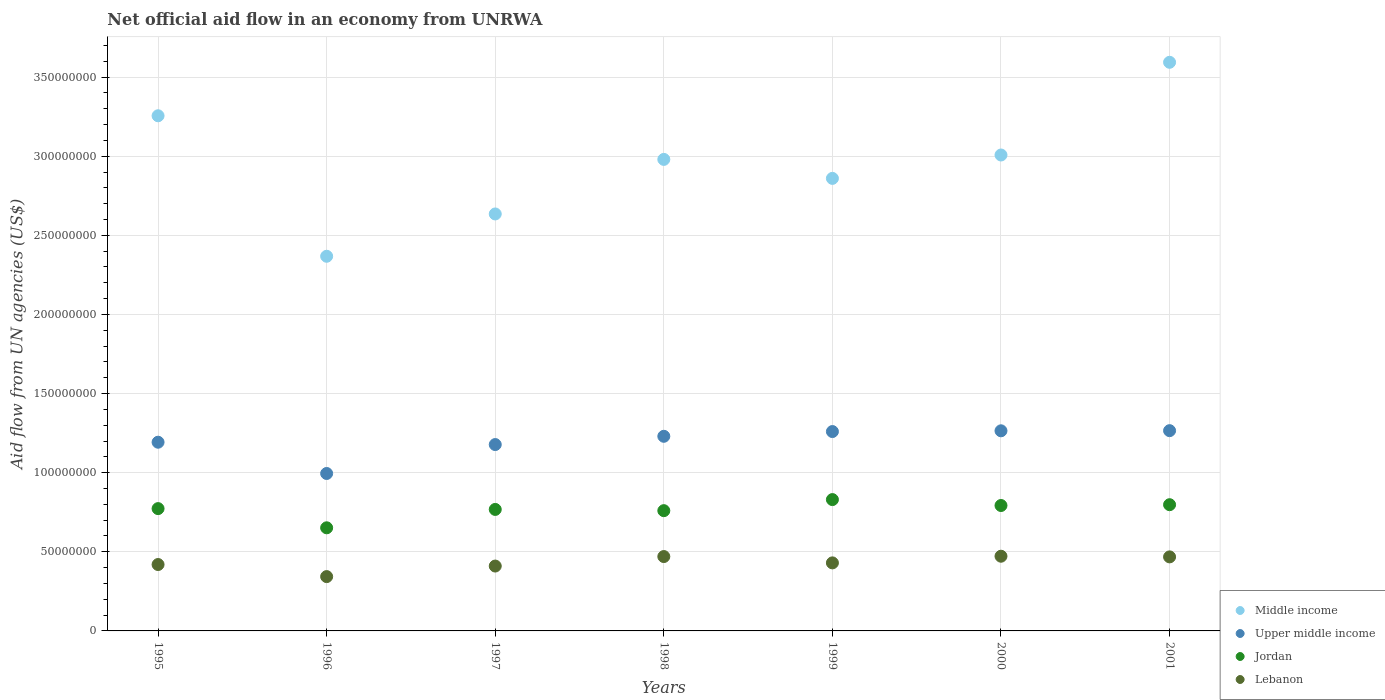What is the net official aid flow in Lebanon in 1999?
Ensure brevity in your answer.  4.30e+07. Across all years, what is the maximum net official aid flow in Upper middle income?
Your answer should be very brief. 1.27e+08. Across all years, what is the minimum net official aid flow in Upper middle income?
Offer a terse response. 9.95e+07. In which year was the net official aid flow in Middle income minimum?
Your answer should be very brief. 1996. What is the total net official aid flow in Upper middle income in the graph?
Offer a terse response. 8.39e+08. What is the difference between the net official aid flow in Lebanon in 1997 and that in 1998?
Keep it short and to the point. -6.00e+06. What is the difference between the net official aid flow in Jordan in 1998 and the net official aid flow in Middle income in 2001?
Keep it short and to the point. -2.83e+08. What is the average net official aid flow in Jordan per year?
Give a very brief answer. 7.68e+07. In the year 2001, what is the difference between the net official aid flow in Upper middle income and net official aid flow in Middle income?
Offer a terse response. -2.33e+08. What is the ratio of the net official aid flow in Upper middle income in 1999 to that in 2000?
Your response must be concise. 1. Is the net official aid flow in Lebanon in 1998 less than that in 2000?
Offer a very short reply. Yes. What is the difference between the highest and the second highest net official aid flow in Middle income?
Keep it short and to the point. 3.38e+07. What is the difference between the highest and the lowest net official aid flow in Jordan?
Provide a succinct answer. 1.78e+07. In how many years, is the net official aid flow in Lebanon greater than the average net official aid flow in Lebanon taken over all years?
Ensure brevity in your answer.  3. Is the sum of the net official aid flow in Upper middle income in 1997 and 1999 greater than the maximum net official aid flow in Jordan across all years?
Ensure brevity in your answer.  Yes. Is it the case that in every year, the sum of the net official aid flow in Jordan and net official aid flow in Upper middle income  is greater than the sum of net official aid flow in Middle income and net official aid flow in Lebanon?
Your answer should be compact. No. Does the net official aid flow in Lebanon monotonically increase over the years?
Your answer should be very brief. No. Is the net official aid flow in Upper middle income strictly greater than the net official aid flow in Jordan over the years?
Offer a very short reply. Yes. Is the net official aid flow in Jordan strictly less than the net official aid flow in Middle income over the years?
Your answer should be very brief. Yes. What is the difference between two consecutive major ticks on the Y-axis?
Ensure brevity in your answer.  5.00e+07. Does the graph contain any zero values?
Provide a short and direct response. No. Does the graph contain grids?
Offer a very short reply. Yes. How are the legend labels stacked?
Ensure brevity in your answer.  Vertical. What is the title of the graph?
Your answer should be compact. Net official aid flow in an economy from UNRWA. Does "United States" appear as one of the legend labels in the graph?
Give a very brief answer. No. What is the label or title of the Y-axis?
Your response must be concise. Aid flow from UN agencies (US$). What is the Aid flow from UN agencies (US$) in Middle income in 1995?
Provide a succinct answer. 3.26e+08. What is the Aid flow from UN agencies (US$) of Upper middle income in 1995?
Your answer should be very brief. 1.19e+08. What is the Aid flow from UN agencies (US$) of Jordan in 1995?
Ensure brevity in your answer.  7.73e+07. What is the Aid flow from UN agencies (US$) of Lebanon in 1995?
Provide a short and direct response. 4.20e+07. What is the Aid flow from UN agencies (US$) of Middle income in 1996?
Your answer should be compact. 2.37e+08. What is the Aid flow from UN agencies (US$) of Upper middle income in 1996?
Ensure brevity in your answer.  9.95e+07. What is the Aid flow from UN agencies (US$) in Jordan in 1996?
Your response must be concise. 6.52e+07. What is the Aid flow from UN agencies (US$) in Lebanon in 1996?
Your answer should be very brief. 3.43e+07. What is the Aid flow from UN agencies (US$) in Middle income in 1997?
Your answer should be compact. 2.64e+08. What is the Aid flow from UN agencies (US$) of Upper middle income in 1997?
Keep it short and to the point. 1.18e+08. What is the Aid flow from UN agencies (US$) of Jordan in 1997?
Make the answer very short. 7.68e+07. What is the Aid flow from UN agencies (US$) of Lebanon in 1997?
Your answer should be compact. 4.10e+07. What is the Aid flow from UN agencies (US$) in Middle income in 1998?
Provide a short and direct response. 2.98e+08. What is the Aid flow from UN agencies (US$) of Upper middle income in 1998?
Offer a terse response. 1.23e+08. What is the Aid flow from UN agencies (US$) in Jordan in 1998?
Provide a short and direct response. 7.60e+07. What is the Aid flow from UN agencies (US$) of Lebanon in 1998?
Keep it short and to the point. 4.70e+07. What is the Aid flow from UN agencies (US$) of Middle income in 1999?
Your answer should be very brief. 2.86e+08. What is the Aid flow from UN agencies (US$) in Upper middle income in 1999?
Make the answer very short. 1.26e+08. What is the Aid flow from UN agencies (US$) in Jordan in 1999?
Your answer should be compact. 8.30e+07. What is the Aid flow from UN agencies (US$) of Lebanon in 1999?
Offer a very short reply. 4.30e+07. What is the Aid flow from UN agencies (US$) of Middle income in 2000?
Offer a very short reply. 3.01e+08. What is the Aid flow from UN agencies (US$) of Upper middle income in 2000?
Provide a short and direct response. 1.26e+08. What is the Aid flow from UN agencies (US$) of Jordan in 2000?
Provide a short and direct response. 7.93e+07. What is the Aid flow from UN agencies (US$) of Lebanon in 2000?
Keep it short and to the point. 4.72e+07. What is the Aid flow from UN agencies (US$) in Middle income in 2001?
Your answer should be very brief. 3.59e+08. What is the Aid flow from UN agencies (US$) of Upper middle income in 2001?
Give a very brief answer. 1.27e+08. What is the Aid flow from UN agencies (US$) of Jordan in 2001?
Make the answer very short. 7.98e+07. What is the Aid flow from UN agencies (US$) of Lebanon in 2001?
Give a very brief answer. 4.68e+07. Across all years, what is the maximum Aid flow from UN agencies (US$) in Middle income?
Provide a short and direct response. 3.59e+08. Across all years, what is the maximum Aid flow from UN agencies (US$) of Upper middle income?
Offer a terse response. 1.27e+08. Across all years, what is the maximum Aid flow from UN agencies (US$) in Jordan?
Your answer should be compact. 8.30e+07. Across all years, what is the maximum Aid flow from UN agencies (US$) in Lebanon?
Offer a very short reply. 4.72e+07. Across all years, what is the minimum Aid flow from UN agencies (US$) in Middle income?
Keep it short and to the point. 2.37e+08. Across all years, what is the minimum Aid flow from UN agencies (US$) in Upper middle income?
Keep it short and to the point. 9.95e+07. Across all years, what is the minimum Aid flow from UN agencies (US$) of Jordan?
Provide a short and direct response. 6.52e+07. Across all years, what is the minimum Aid flow from UN agencies (US$) in Lebanon?
Offer a terse response. 3.43e+07. What is the total Aid flow from UN agencies (US$) in Middle income in the graph?
Your answer should be compact. 2.07e+09. What is the total Aid flow from UN agencies (US$) in Upper middle income in the graph?
Your answer should be very brief. 8.39e+08. What is the total Aid flow from UN agencies (US$) of Jordan in the graph?
Offer a terse response. 5.37e+08. What is the total Aid flow from UN agencies (US$) in Lebanon in the graph?
Provide a succinct answer. 3.01e+08. What is the difference between the Aid flow from UN agencies (US$) of Middle income in 1995 and that in 1996?
Keep it short and to the point. 8.88e+07. What is the difference between the Aid flow from UN agencies (US$) of Upper middle income in 1995 and that in 1996?
Keep it short and to the point. 1.98e+07. What is the difference between the Aid flow from UN agencies (US$) of Jordan in 1995 and that in 1996?
Your answer should be very brief. 1.21e+07. What is the difference between the Aid flow from UN agencies (US$) in Lebanon in 1995 and that in 1996?
Make the answer very short. 7.63e+06. What is the difference between the Aid flow from UN agencies (US$) in Middle income in 1995 and that in 1997?
Keep it short and to the point. 6.20e+07. What is the difference between the Aid flow from UN agencies (US$) in Upper middle income in 1995 and that in 1997?
Offer a terse response. 1.48e+06. What is the difference between the Aid flow from UN agencies (US$) of Jordan in 1995 and that in 1997?
Provide a succinct answer. 5.20e+05. What is the difference between the Aid flow from UN agencies (US$) of Lebanon in 1995 and that in 1997?
Give a very brief answer. 9.60e+05. What is the difference between the Aid flow from UN agencies (US$) of Middle income in 1995 and that in 1998?
Ensure brevity in your answer.  2.76e+07. What is the difference between the Aid flow from UN agencies (US$) in Upper middle income in 1995 and that in 1998?
Provide a succinct answer. -3.74e+06. What is the difference between the Aid flow from UN agencies (US$) of Jordan in 1995 and that in 1998?
Offer a very short reply. 1.30e+06. What is the difference between the Aid flow from UN agencies (US$) in Lebanon in 1995 and that in 1998?
Your response must be concise. -5.04e+06. What is the difference between the Aid flow from UN agencies (US$) in Middle income in 1995 and that in 1999?
Make the answer very short. 3.96e+07. What is the difference between the Aid flow from UN agencies (US$) in Upper middle income in 1995 and that in 1999?
Make the answer very short. -6.74e+06. What is the difference between the Aid flow from UN agencies (US$) in Jordan in 1995 and that in 1999?
Ensure brevity in your answer.  -5.70e+06. What is the difference between the Aid flow from UN agencies (US$) of Lebanon in 1995 and that in 1999?
Your answer should be very brief. -1.04e+06. What is the difference between the Aid flow from UN agencies (US$) in Middle income in 1995 and that in 2000?
Provide a succinct answer. 2.48e+07. What is the difference between the Aid flow from UN agencies (US$) in Upper middle income in 1995 and that in 2000?
Your response must be concise. -7.21e+06. What is the difference between the Aid flow from UN agencies (US$) of Jordan in 1995 and that in 2000?
Offer a terse response. -1.96e+06. What is the difference between the Aid flow from UN agencies (US$) in Lebanon in 1995 and that in 2000?
Your answer should be very brief. -5.25e+06. What is the difference between the Aid flow from UN agencies (US$) of Middle income in 1995 and that in 2001?
Offer a very short reply. -3.38e+07. What is the difference between the Aid flow from UN agencies (US$) of Upper middle income in 1995 and that in 2001?
Give a very brief answer. -7.30e+06. What is the difference between the Aid flow from UN agencies (US$) of Jordan in 1995 and that in 2001?
Ensure brevity in your answer.  -2.47e+06. What is the difference between the Aid flow from UN agencies (US$) of Lebanon in 1995 and that in 2001?
Offer a terse response. -4.83e+06. What is the difference between the Aid flow from UN agencies (US$) in Middle income in 1996 and that in 1997?
Your answer should be compact. -2.67e+07. What is the difference between the Aid flow from UN agencies (US$) in Upper middle income in 1996 and that in 1997?
Your answer should be compact. -1.83e+07. What is the difference between the Aid flow from UN agencies (US$) in Jordan in 1996 and that in 1997?
Offer a terse response. -1.16e+07. What is the difference between the Aid flow from UN agencies (US$) in Lebanon in 1996 and that in 1997?
Offer a very short reply. -6.67e+06. What is the difference between the Aid flow from UN agencies (US$) of Middle income in 1996 and that in 1998?
Ensure brevity in your answer.  -6.12e+07. What is the difference between the Aid flow from UN agencies (US$) in Upper middle income in 1996 and that in 1998?
Your answer should be compact. -2.35e+07. What is the difference between the Aid flow from UN agencies (US$) in Jordan in 1996 and that in 1998?
Your answer should be compact. -1.08e+07. What is the difference between the Aid flow from UN agencies (US$) of Lebanon in 1996 and that in 1998?
Keep it short and to the point. -1.27e+07. What is the difference between the Aid flow from UN agencies (US$) of Middle income in 1996 and that in 1999?
Your response must be concise. -4.92e+07. What is the difference between the Aid flow from UN agencies (US$) in Upper middle income in 1996 and that in 1999?
Give a very brief answer. -2.65e+07. What is the difference between the Aid flow from UN agencies (US$) of Jordan in 1996 and that in 1999?
Your answer should be very brief. -1.78e+07. What is the difference between the Aid flow from UN agencies (US$) of Lebanon in 1996 and that in 1999?
Provide a short and direct response. -8.67e+06. What is the difference between the Aid flow from UN agencies (US$) in Middle income in 1996 and that in 2000?
Provide a succinct answer. -6.40e+07. What is the difference between the Aid flow from UN agencies (US$) in Upper middle income in 1996 and that in 2000?
Your answer should be very brief. -2.70e+07. What is the difference between the Aid flow from UN agencies (US$) in Jordan in 1996 and that in 2000?
Offer a terse response. -1.41e+07. What is the difference between the Aid flow from UN agencies (US$) of Lebanon in 1996 and that in 2000?
Offer a terse response. -1.29e+07. What is the difference between the Aid flow from UN agencies (US$) in Middle income in 1996 and that in 2001?
Offer a terse response. -1.23e+08. What is the difference between the Aid flow from UN agencies (US$) in Upper middle income in 1996 and that in 2001?
Offer a terse response. -2.71e+07. What is the difference between the Aid flow from UN agencies (US$) of Jordan in 1996 and that in 2001?
Keep it short and to the point. -1.46e+07. What is the difference between the Aid flow from UN agencies (US$) in Lebanon in 1996 and that in 2001?
Make the answer very short. -1.25e+07. What is the difference between the Aid flow from UN agencies (US$) in Middle income in 1997 and that in 1998?
Give a very brief answer. -3.45e+07. What is the difference between the Aid flow from UN agencies (US$) of Upper middle income in 1997 and that in 1998?
Offer a very short reply. -5.22e+06. What is the difference between the Aid flow from UN agencies (US$) in Jordan in 1997 and that in 1998?
Ensure brevity in your answer.  7.80e+05. What is the difference between the Aid flow from UN agencies (US$) in Lebanon in 1997 and that in 1998?
Provide a short and direct response. -6.00e+06. What is the difference between the Aid flow from UN agencies (US$) in Middle income in 1997 and that in 1999?
Your answer should be compact. -2.25e+07. What is the difference between the Aid flow from UN agencies (US$) of Upper middle income in 1997 and that in 1999?
Ensure brevity in your answer.  -8.22e+06. What is the difference between the Aid flow from UN agencies (US$) of Jordan in 1997 and that in 1999?
Your answer should be compact. -6.22e+06. What is the difference between the Aid flow from UN agencies (US$) of Middle income in 1997 and that in 2000?
Your response must be concise. -3.73e+07. What is the difference between the Aid flow from UN agencies (US$) of Upper middle income in 1997 and that in 2000?
Keep it short and to the point. -8.69e+06. What is the difference between the Aid flow from UN agencies (US$) of Jordan in 1997 and that in 2000?
Ensure brevity in your answer.  -2.48e+06. What is the difference between the Aid flow from UN agencies (US$) of Lebanon in 1997 and that in 2000?
Offer a very short reply. -6.21e+06. What is the difference between the Aid flow from UN agencies (US$) of Middle income in 1997 and that in 2001?
Make the answer very short. -9.58e+07. What is the difference between the Aid flow from UN agencies (US$) of Upper middle income in 1997 and that in 2001?
Offer a very short reply. -8.78e+06. What is the difference between the Aid flow from UN agencies (US$) in Jordan in 1997 and that in 2001?
Your answer should be very brief. -2.99e+06. What is the difference between the Aid flow from UN agencies (US$) of Lebanon in 1997 and that in 2001?
Your answer should be very brief. -5.79e+06. What is the difference between the Aid flow from UN agencies (US$) in Middle income in 1998 and that in 1999?
Offer a terse response. 1.20e+07. What is the difference between the Aid flow from UN agencies (US$) in Jordan in 1998 and that in 1999?
Give a very brief answer. -7.00e+06. What is the difference between the Aid flow from UN agencies (US$) in Middle income in 1998 and that in 2000?
Keep it short and to the point. -2.78e+06. What is the difference between the Aid flow from UN agencies (US$) of Upper middle income in 1998 and that in 2000?
Your answer should be compact. -3.47e+06. What is the difference between the Aid flow from UN agencies (US$) in Jordan in 1998 and that in 2000?
Give a very brief answer. -3.26e+06. What is the difference between the Aid flow from UN agencies (US$) in Lebanon in 1998 and that in 2000?
Your answer should be very brief. -2.10e+05. What is the difference between the Aid flow from UN agencies (US$) of Middle income in 1998 and that in 2001?
Keep it short and to the point. -6.14e+07. What is the difference between the Aid flow from UN agencies (US$) of Upper middle income in 1998 and that in 2001?
Your answer should be very brief. -3.56e+06. What is the difference between the Aid flow from UN agencies (US$) of Jordan in 1998 and that in 2001?
Your answer should be compact. -3.77e+06. What is the difference between the Aid flow from UN agencies (US$) in Middle income in 1999 and that in 2000?
Give a very brief answer. -1.48e+07. What is the difference between the Aid flow from UN agencies (US$) of Upper middle income in 1999 and that in 2000?
Provide a succinct answer. -4.70e+05. What is the difference between the Aid flow from UN agencies (US$) of Jordan in 1999 and that in 2000?
Offer a very short reply. 3.74e+06. What is the difference between the Aid flow from UN agencies (US$) of Lebanon in 1999 and that in 2000?
Your answer should be very brief. -4.21e+06. What is the difference between the Aid flow from UN agencies (US$) in Middle income in 1999 and that in 2001?
Your response must be concise. -7.34e+07. What is the difference between the Aid flow from UN agencies (US$) of Upper middle income in 1999 and that in 2001?
Provide a succinct answer. -5.60e+05. What is the difference between the Aid flow from UN agencies (US$) of Jordan in 1999 and that in 2001?
Make the answer very short. 3.23e+06. What is the difference between the Aid flow from UN agencies (US$) in Lebanon in 1999 and that in 2001?
Give a very brief answer. -3.79e+06. What is the difference between the Aid flow from UN agencies (US$) in Middle income in 2000 and that in 2001?
Give a very brief answer. -5.86e+07. What is the difference between the Aid flow from UN agencies (US$) of Upper middle income in 2000 and that in 2001?
Make the answer very short. -9.00e+04. What is the difference between the Aid flow from UN agencies (US$) of Jordan in 2000 and that in 2001?
Ensure brevity in your answer.  -5.10e+05. What is the difference between the Aid flow from UN agencies (US$) in Lebanon in 2000 and that in 2001?
Provide a short and direct response. 4.20e+05. What is the difference between the Aid flow from UN agencies (US$) in Middle income in 1995 and the Aid flow from UN agencies (US$) in Upper middle income in 1996?
Offer a very short reply. 2.26e+08. What is the difference between the Aid flow from UN agencies (US$) in Middle income in 1995 and the Aid flow from UN agencies (US$) in Jordan in 1996?
Your answer should be very brief. 2.60e+08. What is the difference between the Aid flow from UN agencies (US$) of Middle income in 1995 and the Aid flow from UN agencies (US$) of Lebanon in 1996?
Keep it short and to the point. 2.91e+08. What is the difference between the Aid flow from UN agencies (US$) in Upper middle income in 1995 and the Aid flow from UN agencies (US$) in Jordan in 1996?
Give a very brief answer. 5.41e+07. What is the difference between the Aid flow from UN agencies (US$) in Upper middle income in 1995 and the Aid flow from UN agencies (US$) in Lebanon in 1996?
Give a very brief answer. 8.49e+07. What is the difference between the Aid flow from UN agencies (US$) in Jordan in 1995 and the Aid flow from UN agencies (US$) in Lebanon in 1996?
Your answer should be compact. 4.30e+07. What is the difference between the Aid flow from UN agencies (US$) in Middle income in 1995 and the Aid flow from UN agencies (US$) in Upper middle income in 1997?
Provide a succinct answer. 2.08e+08. What is the difference between the Aid flow from UN agencies (US$) of Middle income in 1995 and the Aid flow from UN agencies (US$) of Jordan in 1997?
Provide a succinct answer. 2.49e+08. What is the difference between the Aid flow from UN agencies (US$) in Middle income in 1995 and the Aid flow from UN agencies (US$) in Lebanon in 1997?
Provide a succinct answer. 2.85e+08. What is the difference between the Aid flow from UN agencies (US$) of Upper middle income in 1995 and the Aid flow from UN agencies (US$) of Jordan in 1997?
Keep it short and to the point. 4.25e+07. What is the difference between the Aid flow from UN agencies (US$) of Upper middle income in 1995 and the Aid flow from UN agencies (US$) of Lebanon in 1997?
Offer a very short reply. 7.83e+07. What is the difference between the Aid flow from UN agencies (US$) in Jordan in 1995 and the Aid flow from UN agencies (US$) in Lebanon in 1997?
Keep it short and to the point. 3.63e+07. What is the difference between the Aid flow from UN agencies (US$) of Middle income in 1995 and the Aid flow from UN agencies (US$) of Upper middle income in 1998?
Provide a succinct answer. 2.03e+08. What is the difference between the Aid flow from UN agencies (US$) in Middle income in 1995 and the Aid flow from UN agencies (US$) in Jordan in 1998?
Your answer should be very brief. 2.50e+08. What is the difference between the Aid flow from UN agencies (US$) in Middle income in 1995 and the Aid flow from UN agencies (US$) in Lebanon in 1998?
Your answer should be very brief. 2.79e+08. What is the difference between the Aid flow from UN agencies (US$) in Upper middle income in 1995 and the Aid flow from UN agencies (US$) in Jordan in 1998?
Provide a succinct answer. 4.33e+07. What is the difference between the Aid flow from UN agencies (US$) in Upper middle income in 1995 and the Aid flow from UN agencies (US$) in Lebanon in 1998?
Provide a short and direct response. 7.23e+07. What is the difference between the Aid flow from UN agencies (US$) in Jordan in 1995 and the Aid flow from UN agencies (US$) in Lebanon in 1998?
Provide a succinct answer. 3.03e+07. What is the difference between the Aid flow from UN agencies (US$) in Middle income in 1995 and the Aid flow from UN agencies (US$) in Upper middle income in 1999?
Offer a very short reply. 2.00e+08. What is the difference between the Aid flow from UN agencies (US$) in Middle income in 1995 and the Aid flow from UN agencies (US$) in Jordan in 1999?
Your answer should be compact. 2.43e+08. What is the difference between the Aid flow from UN agencies (US$) in Middle income in 1995 and the Aid flow from UN agencies (US$) in Lebanon in 1999?
Your response must be concise. 2.83e+08. What is the difference between the Aid flow from UN agencies (US$) of Upper middle income in 1995 and the Aid flow from UN agencies (US$) of Jordan in 1999?
Provide a short and direct response. 3.63e+07. What is the difference between the Aid flow from UN agencies (US$) in Upper middle income in 1995 and the Aid flow from UN agencies (US$) in Lebanon in 1999?
Provide a succinct answer. 7.63e+07. What is the difference between the Aid flow from UN agencies (US$) in Jordan in 1995 and the Aid flow from UN agencies (US$) in Lebanon in 1999?
Your answer should be compact. 3.43e+07. What is the difference between the Aid flow from UN agencies (US$) of Middle income in 1995 and the Aid flow from UN agencies (US$) of Upper middle income in 2000?
Your answer should be compact. 1.99e+08. What is the difference between the Aid flow from UN agencies (US$) in Middle income in 1995 and the Aid flow from UN agencies (US$) in Jordan in 2000?
Provide a short and direct response. 2.46e+08. What is the difference between the Aid flow from UN agencies (US$) in Middle income in 1995 and the Aid flow from UN agencies (US$) in Lebanon in 2000?
Give a very brief answer. 2.78e+08. What is the difference between the Aid flow from UN agencies (US$) in Upper middle income in 1995 and the Aid flow from UN agencies (US$) in Jordan in 2000?
Provide a short and direct response. 4.00e+07. What is the difference between the Aid flow from UN agencies (US$) in Upper middle income in 1995 and the Aid flow from UN agencies (US$) in Lebanon in 2000?
Ensure brevity in your answer.  7.20e+07. What is the difference between the Aid flow from UN agencies (US$) in Jordan in 1995 and the Aid flow from UN agencies (US$) in Lebanon in 2000?
Offer a very short reply. 3.01e+07. What is the difference between the Aid flow from UN agencies (US$) of Middle income in 1995 and the Aid flow from UN agencies (US$) of Upper middle income in 2001?
Ensure brevity in your answer.  1.99e+08. What is the difference between the Aid flow from UN agencies (US$) of Middle income in 1995 and the Aid flow from UN agencies (US$) of Jordan in 2001?
Your response must be concise. 2.46e+08. What is the difference between the Aid flow from UN agencies (US$) in Middle income in 1995 and the Aid flow from UN agencies (US$) in Lebanon in 2001?
Keep it short and to the point. 2.79e+08. What is the difference between the Aid flow from UN agencies (US$) in Upper middle income in 1995 and the Aid flow from UN agencies (US$) in Jordan in 2001?
Your response must be concise. 3.95e+07. What is the difference between the Aid flow from UN agencies (US$) of Upper middle income in 1995 and the Aid flow from UN agencies (US$) of Lebanon in 2001?
Provide a succinct answer. 7.25e+07. What is the difference between the Aid flow from UN agencies (US$) in Jordan in 1995 and the Aid flow from UN agencies (US$) in Lebanon in 2001?
Make the answer very short. 3.05e+07. What is the difference between the Aid flow from UN agencies (US$) of Middle income in 1996 and the Aid flow from UN agencies (US$) of Upper middle income in 1997?
Provide a succinct answer. 1.19e+08. What is the difference between the Aid flow from UN agencies (US$) of Middle income in 1996 and the Aid flow from UN agencies (US$) of Jordan in 1997?
Your answer should be compact. 1.60e+08. What is the difference between the Aid flow from UN agencies (US$) of Middle income in 1996 and the Aid flow from UN agencies (US$) of Lebanon in 1997?
Offer a terse response. 1.96e+08. What is the difference between the Aid flow from UN agencies (US$) in Upper middle income in 1996 and the Aid flow from UN agencies (US$) in Jordan in 1997?
Make the answer very short. 2.27e+07. What is the difference between the Aid flow from UN agencies (US$) of Upper middle income in 1996 and the Aid flow from UN agencies (US$) of Lebanon in 1997?
Make the answer very short. 5.85e+07. What is the difference between the Aid flow from UN agencies (US$) in Jordan in 1996 and the Aid flow from UN agencies (US$) in Lebanon in 1997?
Keep it short and to the point. 2.42e+07. What is the difference between the Aid flow from UN agencies (US$) of Middle income in 1996 and the Aid flow from UN agencies (US$) of Upper middle income in 1998?
Your answer should be very brief. 1.14e+08. What is the difference between the Aid flow from UN agencies (US$) of Middle income in 1996 and the Aid flow from UN agencies (US$) of Jordan in 1998?
Provide a succinct answer. 1.61e+08. What is the difference between the Aid flow from UN agencies (US$) of Middle income in 1996 and the Aid flow from UN agencies (US$) of Lebanon in 1998?
Your response must be concise. 1.90e+08. What is the difference between the Aid flow from UN agencies (US$) in Upper middle income in 1996 and the Aid flow from UN agencies (US$) in Jordan in 1998?
Make the answer very short. 2.35e+07. What is the difference between the Aid flow from UN agencies (US$) of Upper middle income in 1996 and the Aid flow from UN agencies (US$) of Lebanon in 1998?
Make the answer very short. 5.25e+07. What is the difference between the Aid flow from UN agencies (US$) of Jordan in 1996 and the Aid flow from UN agencies (US$) of Lebanon in 1998?
Your response must be concise. 1.82e+07. What is the difference between the Aid flow from UN agencies (US$) in Middle income in 1996 and the Aid flow from UN agencies (US$) in Upper middle income in 1999?
Offer a very short reply. 1.11e+08. What is the difference between the Aid flow from UN agencies (US$) in Middle income in 1996 and the Aid flow from UN agencies (US$) in Jordan in 1999?
Offer a terse response. 1.54e+08. What is the difference between the Aid flow from UN agencies (US$) of Middle income in 1996 and the Aid flow from UN agencies (US$) of Lebanon in 1999?
Offer a very short reply. 1.94e+08. What is the difference between the Aid flow from UN agencies (US$) in Upper middle income in 1996 and the Aid flow from UN agencies (US$) in Jordan in 1999?
Your response must be concise. 1.65e+07. What is the difference between the Aid flow from UN agencies (US$) of Upper middle income in 1996 and the Aid flow from UN agencies (US$) of Lebanon in 1999?
Ensure brevity in your answer.  5.65e+07. What is the difference between the Aid flow from UN agencies (US$) in Jordan in 1996 and the Aid flow from UN agencies (US$) in Lebanon in 1999?
Your answer should be very brief. 2.22e+07. What is the difference between the Aid flow from UN agencies (US$) in Middle income in 1996 and the Aid flow from UN agencies (US$) in Upper middle income in 2000?
Make the answer very short. 1.10e+08. What is the difference between the Aid flow from UN agencies (US$) in Middle income in 1996 and the Aid flow from UN agencies (US$) in Jordan in 2000?
Offer a terse response. 1.58e+08. What is the difference between the Aid flow from UN agencies (US$) in Middle income in 1996 and the Aid flow from UN agencies (US$) in Lebanon in 2000?
Provide a short and direct response. 1.90e+08. What is the difference between the Aid flow from UN agencies (US$) of Upper middle income in 1996 and the Aid flow from UN agencies (US$) of Jordan in 2000?
Give a very brief answer. 2.02e+07. What is the difference between the Aid flow from UN agencies (US$) of Upper middle income in 1996 and the Aid flow from UN agencies (US$) of Lebanon in 2000?
Make the answer very short. 5.23e+07. What is the difference between the Aid flow from UN agencies (US$) of Jordan in 1996 and the Aid flow from UN agencies (US$) of Lebanon in 2000?
Ensure brevity in your answer.  1.80e+07. What is the difference between the Aid flow from UN agencies (US$) of Middle income in 1996 and the Aid flow from UN agencies (US$) of Upper middle income in 2001?
Offer a very short reply. 1.10e+08. What is the difference between the Aid flow from UN agencies (US$) in Middle income in 1996 and the Aid flow from UN agencies (US$) in Jordan in 2001?
Make the answer very short. 1.57e+08. What is the difference between the Aid flow from UN agencies (US$) in Middle income in 1996 and the Aid flow from UN agencies (US$) in Lebanon in 2001?
Your answer should be compact. 1.90e+08. What is the difference between the Aid flow from UN agencies (US$) in Upper middle income in 1996 and the Aid flow from UN agencies (US$) in Jordan in 2001?
Your answer should be compact. 1.97e+07. What is the difference between the Aid flow from UN agencies (US$) in Upper middle income in 1996 and the Aid flow from UN agencies (US$) in Lebanon in 2001?
Your answer should be very brief. 5.27e+07. What is the difference between the Aid flow from UN agencies (US$) in Jordan in 1996 and the Aid flow from UN agencies (US$) in Lebanon in 2001?
Make the answer very short. 1.84e+07. What is the difference between the Aid flow from UN agencies (US$) in Middle income in 1997 and the Aid flow from UN agencies (US$) in Upper middle income in 1998?
Give a very brief answer. 1.41e+08. What is the difference between the Aid flow from UN agencies (US$) of Middle income in 1997 and the Aid flow from UN agencies (US$) of Jordan in 1998?
Keep it short and to the point. 1.88e+08. What is the difference between the Aid flow from UN agencies (US$) of Middle income in 1997 and the Aid flow from UN agencies (US$) of Lebanon in 1998?
Ensure brevity in your answer.  2.17e+08. What is the difference between the Aid flow from UN agencies (US$) of Upper middle income in 1997 and the Aid flow from UN agencies (US$) of Jordan in 1998?
Provide a succinct answer. 4.18e+07. What is the difference between the Aid flow from UN agencies (US$) of Upper middle income in 1997 and the Aid flow from UN agencies (US$) of Lebanon in 1998?
Offer a very short reply. 7.08e+07. What is the difference between the Aid flow from UN agencies (US$) of Jordan in 1997 and the Aid flow from UN agencies (US$) of Lebanon in 1998?
Keep it short and to the point. 2.98e+07. What is the difference between the Aid flow from UN agencies (US$) in Middle income in 1997 and the Aid flow from UN agencies (US$) in Upper middle income in 1999?
Keep it short and to the point. 1.38e+08. What is the difference between the Aid flow from UN agencies (US$) in Middle income in 1997 and the Aid flow from UN agencies (US$) in Jordan in 1999?
Your answer should be very brief. 1.81e+08. What is the difference between the Aid flow from UN agencies (US$) of Middle income in 1997 and the Aid flow from UN agencies (US$) of Lebanon in 1999?
Offer a terse response. 2.21e+08. What is the difference between the Aid flow from UN agencies (US$) of Upper middle income in 1997 and the Aid flow from UN agencies (US$) of Jordan in 1999?
Give a very brief answer. 3.48e+07. What is the difference between the Aid flow from UN agencies (US$) of Upper middle income in 1997 and the Aid flow from UN agencies (US$) of Lebanon in 1999?
Your response must be concise. 7.48e+07. What is the difference between the Aid flow from UN agencies (US$) of Jordan in 1997 and the Aid flow from UN agencies (US$) of Lebanon in 1999?
Offer a very short reply. 3.38e+07. What is the difference between the Aid flow from UN agencies (US$) of Middle income in 1997 and the Aid flow from UN agencies (US$) of Upper middle income in 2000?
Give a very brief answer. 1.37e+08. What is the difference between the Aid flow from UN agencies (US$) of Middle income in 1997 and the Aid flow from UN agencies (US$) of Jordan in 2000?
Keep it short and to the point. 1.84e+08. What is the difference between the Aid flow from UN agencies (US$) of Middle income in 1997 and the Aid flow from UN agencies (US$) of Lebanon in 2000?
Your response must be concise. 2.16e+08. What is the difference between the Aid flow from UN agencies (US$) of Upper middle income in 1997 and the Aid flow from UN agencies (US$) of Jordan in 2000?
Offer a terse response. 3.85e+07. What is the difference between the Aid flow from UN agencies (US$) in Upper middle income in 1997 and the Aid flow from UN agencies (US$) in Lebanon in 2000?
Make the answer very short. 7.06e+07. What is the difference between the Aid flow from UN agencies (US$) in Jordan in 1997 and the Aid flow from UN agencies (US$) in Lebanon in 2000?
Offer a very short reply. 2.96e+07. What is the difference between the Aid flow from UN agencies (US$) of Middle income in 1997 and the Aid flow from UN agencies (US$) of Upper middle income in 2001?
Ensure brevity in your answer.  1.37e+08. What is the difference between the Aid flow from UN agencies (US$) of Middle income in 1997 and the Aid flow from UN agencies (US$) of Jordan in 2001?
Provide a short and direct response. 1.84e+08. What is the difference between the Aid flow from UN agencies (US$) of Middle income in 1997 and the Aid flow from UN agencies (US$) of Lebanon in 2001?
Your answer should be very brief. 2.17e+08. What is the difference between the Aid flow from UN agencies (US$) in Upper middle income in 1997 and the Aid flow from UN agencies (US$) in Jordan in 2001?
Your response must be concise. 3.80e+07. What is the difference between the Aid flow from UN agencies (US$) in Upper middle income in 1997 and the Aid flow from UN agencies (US$) in Lebanon in 2001?
Offer a very short reply. 7.10e+07. What is the difference between the Aid flow from UN agencies (US$) in Jordan in 1997 and the Aid flow from UN agencies (US$) in Lebanon in 2001?
Provide a short and direct response. 3.00e+07. What is the difference between the Aid flow from UN agencies (US$) in Middle income in 1998 and the Aid flow from UN agencies (US$) in Upper middle income in 1999?
Provide a succinct answer. 1.72e+08. What is the difference between the Aid flow from UN agencies (US$) in Middle income in 1998 and the Aid flow from UN agencies (US$) in Jordan in 1999?
Ensure brevity in your answer.  2.15e+08. What is the difference between the Aid flow from UN agencies (US$) of Middle income in 1998 and the Aid flow from UN agencies (US$) of Lebanon in 1999?
Keep it short and to the point. 2.55e+08. What is the difference between the Aid flow from UN agencies (US$) in Upper middle income in 1998 and the Aid flow from UN agencies (US$) in Jordan in 1999?
Make the answer very short. 4.00e+07. What is the difference between the Aid flow from UN agencies (US$) of Upper middle income in 1998 and the Aid flow from UN agencies (US$) of Lebanon in 1999?
Offer a very short reply. 8.00e+07. What is the difference between the Aid flow from UN agencies (US$) in Jordan in 1998 and the Aid flow from UN agencies (US$) in Lebanon in 1999?
Offer a very short reply. 3.30e+07. What is the difference between the Aid flow from UN agencies (US$) in Middle income in 1998 and the Aid flow from UN agencies (US$) in Upper middle income in 2000?
Make the answer very short. 1.72e+08. What is the difference between the Aid flow from UN agencies (US$) of Middle income in 1998 and the Aid flow from UN agencies (US$) of Jordan in 2000?
Ensure brevity in your answer.  2.19e+08. What is the difference between the Aid flow from UN agencies (US$) of Middle income in 1998 and the Aid flow from UN agencies (US$) of Lebanon in 2000?
Your answer should be compact. 2.51e+08. What is the difference between the Aid flow from UN agencies (US$) in Upper middle income in 1998 and the Aid flow from UN agencies (US$) in Jordan in 2000?
Offer a terse response. 4.37e+07. What is the difference between the Aid flow from UN agencies (US$) in Upper middle income in 1998 and the Aid flow from UN agencies (US$) in Lebanon in 2000?
Offer a terse response. 7.58e+07. What is the difference between the Aid flow from UN agencies (US$) in Jordan in 1998 and the Aid flow from UN agencies (US$) in Lebanon in 2000?
Make the answer very short. 2.88e+07. What is the difference between the Aid flow from UN agencies (US$) in Middle income in 1998 and the Aid flow from UN agencies (US$) in Upper middle income in 2001?
Give a very brief answer. 1.71e+08. What is the difference between the Aid flow from UN agencies (US$) in Middle income in 1998 and the Aid flow from UN agencies (US$) in Jordan in 2001?
Provide a short and direct response. 2.18e+08. What is the difference between the Aid flow from UN agencies (US$) of Middle income in 1998 and the Aid flow from UN agencies (US$) of Lebanon in 2001?
Keep it short and to the point. 2.51e+08. What is the difference between the Aid flow from UN agencies (US$) of Upper middle income in 1998 and the Aid flow from UN agencies (US$) of Jordan in 2001?
Provide a succinct answer. 4.32e+07. What is the difference between the Aid flow from UN agencies (US$) of Upper middle income in 1998 and the Aid flow from UN agencies (US$) of Lebanon in 2001?
Provide a succinct answer. 7.62e+07. What is the difference between the Aid flow from UN agencies (US$) of Jordan in 1998 and the Aid flow from UN agencies (US$) of Lebanon in 2001?
Provide a short and direct response. 2.92e+07. What is the difference between the Aid flow from UN agencies (US$) in Middle income in 1999 and the Aid flow from UN agencies (US$) in Upper middle income in 2000?
Provide a short and direct response. 1.60e+08. What is the difference between the Aid flow from UN agencies (US$) in Middle income in 1999 and the Aid flow from UN agencies (US$) in Jordan in 2000?
Give a very brief answer. 2.07e+08. What is the difference between the Aid flow from UN agencies (US$) in Middle income in 1999 and the Aid flow from UN agencies (US$) in Lebanon in 2000?
Provide a short and direct response. 2.39e+08. What is the difference between the Aid flow from UN agencies (US$) of Upper middle income in 1999 and the Aid flow from UN agencies (US$) of Jordan in 2000?
Ensure brevity in your answer.  4.67e+07. What is the difference between the Aid flow from UN agencies (US$) in Upper middle income in 1999 and the Aid flow from UN agencies (US$) in Lebanon in 2000?
Your response must be concise. 7.88e+07. What is the difference between the Aid flow from UN agencies (US$) of Jordan in 1999 and the Aid flow from UN agencies (US$) of Lebanon in 2000?
Offer a terse response. 3.58e+07. What is the difference between the Aid flow from UN agencies (US$) of Middle income in 1999 and the Aid flow from UN agencies (US$) of Upper middle income in 2001?
Give a very brief answer. 1.59e+08. What is the difference between the Aid flow from UN agencies (US$) of Middle income in 1999 and the Aid flow from UN agencies (US$) of Jordan in 2001?
Offer a very short reply. 2.06e+08. What is the difference between the Aid flow from UN agencies (US$) of Middle income in 1999 and the Aid flow from UN agencies (US$) of Lebanon in 2001?
Make the answer very short. 2.39e+08. What is the difference between the Aid flow from UN agencies (US$) of Upper middle income in 1999 and the Aid flow from UN agencies (US$) of Jordan in 2001?
Your answer should be very brief. 4.62e+07. What is the difference between the Aid flow from UN agencies (US$) in Upper middle income in 1999 and the Aid flow from UN agencies (US$) in Lebanon in 2001?
Offer a terse response. 7.92e+07. What is the difference between the Aid flow from UN agencies (US$) of Jordan in 1999 and the Aid flow from UN agencies (US$) of Lebanon in 2001?
Provide a succinct answer. 3.62e+07. What is the difference between the Aid flow from UN agencies (US$) in Middle income in 2000 and the Aid flow from UN agencies (US$) in Upper middle income in 2001?
Provide a succinct answer. 1.74e+08. What is the difference between the Aid flow from UN agencies (US$) in Middle income in 2000 and the Aid flow from UN agencies (US$) in Jordan in 2001?
Give a very brief answer. 2.21e+08. What is the difference between the Aid flow from UN agencies (US$) of Middle income in 2000 and the Aid flow from UN agencies (US$) of Lebanon in 2001?
Make the answer very short. 2.54e+08. What is the difference between the Aid flow from UN agencies (US$) in Upper middle income in 2000 and the Aid flow from UN agencies (US$) in Jordan in 2001?
Offer a very short reply. 4.67e+07. What is the difference between the Aid flow from UN agencies (US$) of Upper middle income in 2000 and the Aid flow from UN agencies (US$) of Lebanon in 2001?
Give a very brief answer. 7.97e+07. What is the difference between the Aid flow from UN agencies (US$) in Jordan in 2000 and the Aid flow from UN agencies (US$) in Lebanon in 2001?
Keep it short and to the point. 3.25e+07. What is the average Aid flow from UN agencies (US$) in Middle income per year?
Ensure brevity in your answer.  2.96e+08. What is the average Aid flow from UN agencies (US$) of Upper middle income per year?
Give a very brief answer. 1.20e+08. What is the average Aid flow from UN agencies (US$) in Jordan per year?
Offer a very short reply. 7.68e+07. What is the average Aid flow from UN agencies (US$) of Lebanon per year?
Offer a terse response. 4.30e+07. In the year 1995, what is the difference between the Aid flow from UN agencies (US$) of Middle income and Aid flow from UN agencies (US$) of Upper middle income?
Make the answer very short. 2.06e+08. In the year 1995, what is the difference between the Aid flow from UN agencies (US$) in Middle income and Aid flow from UN agencies (US$) in Jordan?
Your answer should be very brief. 2.48e+08. In the year 1995, what is the difference between the Aid flow from UN agencies (US$) of Middle income and Aid flow from UN agencies (US$) of Lebanon?
Make the answer very short. 2.84e+08. In the year 1995, what is the difference between the Aid flow from UN agencies (US$) of Upper middle income and Aid flow from UN agencies (US$) of Jordan?
Your response must be concise. 4.20e+07. In the year 1995, what is the difference between the Aid flow from UN agencies (US$) in Upper middle income and Aid flow from UN agencies (US$) in Lebanon?
Keep it short and to the point. 7.73e+07. In the year 1995, what is the difference between the Aid flow from UN agencies (US$) in Jordan and Aid flow from UN agencies (US$) in Lebanon?
Your answer should be very brief. 3.53e+07. In the year 1996, what is the difference between the Aid flow from UN agencies (US$) of Middle income and Aid flow from UN agencies (US$) of Upper middle income?
Your answer should be compact. 1.37e+08. In the year 1996, what is the difference between the Aid flow from UN agencies (US$) of Middle income and Aid flow from UN agencies (US$) of Jordan?
Offer a very short reply. 1.72e+08. In the year 1996, what is the difference between the Aid flow from UN agencies (US$) of Middle income and Aid flow from UN agencies (US$) of Lebanon?
Your response must be concise. 2.02e+08. In the year 1996, what is the difference between the Aid flow from UN agencies (US$) in Upper middle income and Aid flow from UN agencies (US$) in Jordan?
Your response must be concise. 3.43e+07. In the year 1996, what is the difference between the Aid flow from UN agencies (US$) of Upper middle income and Aid flow from UN agencies (US$) of Lebanon?
Your response must be concise. 6.52e+07. In the year 1996, what is the difference between the Aid flow from UN agencies (US$) of Jordan and Aid flow from UN agencies (US$) of Lebanon?
Your response must be concise. 3.08e+07. In the year 1997, what is the difference between the Aid flow from UN agencies (US$) of Middle income and Aid flow from UN agencies (US$) of Upper middle income?
Give a very brief answer. 1.46e+08. In the year 1997, what is the difference between the Aid flow from UN agencies (US$) in Middle income and Aid flow from UN agencies (US$) in Jordan?
Your answer should be compact. 1.87e+08. In the year 1997, what is the difference between the Aid flow from UN agencies (US$) of Middle income and Aid flow from UN agencies (US$) of Lebanon?
Make the answer very short. 2.23e+08. In the year 1997, what is the difference between the Aid flow from UN agencies (US$) in Upper middle income and Aid flow from UN agencies (US$) in Jordan?
Your answer should be very brief. 4.10e+07. In the year 1997, what is the difference between the Aid flow from UN agencies (US$) of Upper middle income and Aid flow from UN agencies (US$) of Lebanon?
Offer a very short reply. 7.68e+07. In the year 1997, what is the difference between the Aid flow from UN agencies (US$) in Jordan and Aid flow from UN agencies (US$) in Lebanon?
Offer a terse response. 3.58e+07. In the year 1998, what is the difference between the Aid flow from UN agencies (US$) in Middle income and Aid flow from UN agencies (US$) in Upper middle income?
Provide a succinct answer. 1.75e+08. In the year 1998, what is the difference between the Aid flow from UN agencies (US$) of Middle income and Aid flow from UN agencies (US$) of Jordan?
Offer a terse response. 2.22e+08. In the year 1998, what is the difference between the Aid flow from UN agencies (US$) in Middle income and Aid flow from UN agencies (US$) in Lebanon?
Give a very brief answer. 2.51e+08. In the year 1998, what is the difference between the Aid flow from UN agencies (US$) in Upper middle income and Aid flow from UN agencies (US$) in Jordan?
Offer a terse response. 4.70e+07. In the year 1998, what is the difference between the Aid flow from UN agencies (US$) of Upper middle income and Aid flow from UN agencies (US$) of Lebanon?
Provide a short and direct response. 7.60e+07. In the year 1998, what is the difference between the Aid flow from UN agencies (US$) of Jordan and Aid flow from UN agencies (US$) of Lebanon?
Your answer should be compact. 2.90e+07. In the year 1999, what is the difference between the Aid flow from UN agencies (US$) of Middle income and Aid flow from UN agencies (US$) of Upper middle income?
Provide a short and direct response. 1.60e+08. In the year 1999, what is the difference between the Aid flow from UN agencies (US$) in Middle income and Aid flow from UN agencies (US$) in Jordan?
Your answer should be compact. 2.03e+08. In the year 1999, what is the difference between the Aid flow from UN agencies (US$) of Middle income and Aid flow from UN agencies (US$) of Lebanon?
Your response must be concise. 2.43e+08. In the year 1999, what is the difference between the Aid flow from UN agencies (US$) of Upper middle income and Aid flow from UN agencies (US$) of Jordan?
Keep it short and to the point. 4.30e+07. In the year 1999, what is the difference between the Aid flow from UN agencies (US$) in Upper middle income and Aid flow from UN agencies (US$) in Lebanon?
Offer a very short reply. 8.30e+07. In the year 1999, what is the difference between the Aid flow from UN agencies (US$) of Jordan and Aid flow from UN agencies (US$) of Lebanon?
Provide a short and direct response. 4.00e+07. In the year 2000, what is the difference between the Aid flow from UN agencies (US$) of Middle income and Aid flow from UN agencies (US$) of Upper middle income?
Keep it short and to the point. 1.74e+08. In the year 2000, what is the difference between the Aid flow from UN agencies (US$) in Middle income and Aid flow from UN agencies (US$) in Jordan?
Offer a very short reply. 2.22e+08. In the year 2000, what is the difference between the Aid flow from UN agencies (US$) in Middle income and Aid flow from UN agencies (US$) in Lebanon?
Your answer should be compact. 2.54e+08. In the year 2000, what is the difference between the Aid flow from UN agencies (US$) of Upper middle income and Aid flow from UN agencies (US$) of Jordan?
Your answer should be very brief. 4.72e+07. In the year 2000, what is the difference between the Aid flow from UN agencies (US$) of Upper middle income and Aid flow from UN agencies (US$) of Lebanon?
Give a very brief answer. 7.93e+07. In the year 2000, what is the difference between the Aid flow from UN agencies (US$) in Jordan and Aid flow from UN agencies (US$) in Lebanon?
Give a very brief answer. 3.20e+07. In the year 2001, what is the difference between the Aid flow from UN agencies (US$) of Middle income and Aid flow from UN agencies (US$) of Upper middle income?
Offer a terse response. 2.33e+08. In the year 2001, what is the difference between the Aid flow from UN agencies (US$) of Middle income and Aid flow from UN agencies (US$) of Jordan?
Your response must be concise. 2.80e+08. In the year 2001, what is the difference between the Aid flow from UN agencies (US$) of Middle income and Aid flow from UN agencies (US$) of Lebanon?
Your response must be concise. 3.13e+08. In the year 2001, what is the difference between the Aid flow from UN agencies (US$) of Upper middle income and Aid flow from UN agencies (US$) of Jordan?
Provide a short and direct response. 4.68e+07. In the year 2001, what is the difference between the Aid flow from UN agencies (US$) of Upper middle income and Aid flow from UN agencies (US$) of Lebanon?
Your answer should be very brief. 7.98e+07. In the year 2001, what is the difference between the Aid flow from UN agencies (US$) in Jordan and Aid flow from UN agencies (US$) in Lebanon?
Offer a terse response. 3.30e+07. What is the ratio of the Aid flow from UN agencies (US$) of Middle income in 1995 to that in 1996?
Your response must be concise. 1.38. What is the ratio of the Aid flow from UN agencies (US$) of Upper middle income in 1995 to that in 1996?
Provide a short and direct response. 1.2. What is the ratio of the Aid flow from UN agencies (US$) of Jordan in 1995 to that in 1996?
Offer a very short reply. 1.19. What is the ratio of the Aid flow from UN agencies (US$) in Lebanon in 1995 to that in 1996?
Provide a succinct answer. 1.22. What is the ratio of the Aid flow from UN agencies (US$) in Middle income in 1995 to that in 1997?
Keep it short and to the point. 1.24. What is the ratio of the Aid flow from UN agencies (US$) in Upper middle income in 1995 to that in 1997?
Your response must be concise. 1.01. What is the ratio of the Aid flow from UN agencies (US$) of Jordan in 1995 to that in 1997?
Provide a short and direct response. 1.01. What is the ratio of the Aid flow from UN agencies (US$) in Lebanon in 1995 to that in 1997?
Give a very brief answer. 1.02. What is the ratio of the Aid flow from UN agencies (US$) in Middle income in 1995 to that in 1998?
Your response must be concise. 1.09. What is the ratio of the Aid flow from UN agencies (US$) of Upper middle income in 1995 to that in 1998?
Your answer should be compact. 0.97. What is the ratio of the Aid flow from UN agencies (US$) of Jordan in 1995 to that in 1998?
Your answer should be very brief. 1.02. What is the ratio of the Aid flow from UN agencies (US$) of Lebanon in 1995 to that in 1998?
Your answer should be very brief. 0.89. What is the ratio of the Aid flow from UN agencies (US$) in Middle income in 1995 to that in 1999?
Ensure brevity in your answer.  1.14. What is the ratio of the Aid flow from UN agencies (US$) of Upper middle income in 1995 to that in 1999?
Give a very brief answer. 0.95. What is the ratio of the Aid flow from UN agencies (US$) of Jordan in 1995 to that in 1999?
Your answer should be compact. 0.93. What is the ratio of the Aid flow from UN agencies (US$) in Lebanon in 1995 to that in 1999?
Give a very brief answer. 0.98. What is the ratio of the Aid flow from UN agencies (US$) of Middle income in 1995 to that in 2000?
Give a very brief answer. 1.08. What is the ratio of the Aid flow from UN agencies (US$) of Upper middle income in 1995 to that in 2000?
Give a very brief answer. 0.94. What is the ratio of the Aid flow from UN agencies (US$) in Jordan in 1995 to that in 2000?
Provide a succinct answer. 0.98. What is the ratio of the Aid flow from UN agencies (US$) of Lebanon in 1995 to that in 2000?
Your answer should be compact. 0.89. What is the ratio of the Aid flow from UN agencies (US$) of Middle income in 1995 to that in 2001?
Your answer should be very brief. 0.91. What is the ratio of the Aid flow from UN agencies (US$) in Upper middle income in 1995 to that in 2001?
Provide a succinct answer. 0.94. What is the ratio of the Aid flow from UN agencies (US$) of Lebanon in 1995 to that in 2001?
Provide a short and direct response. 0.9. What is the ratio of the Aid flow from UN agencies (US$) in Middle income in 1996 to that in 1997?
Your answer should be very brief. 0.9. What is the ratio of the Aid flow from UN agencies (US$) in Upper middle income in 1996 to that in 1997?
Your answer should be very brief. 0.84. What is the ratio of the Aid flow from UN agencies (US$) in Jordan in 1996 to that in 1997?
Your answer should be compact. 0.85. What is the ratio of the Aid flow from UN agencies (US$) of Lebanon in 1996 to that in 1997?
Offer a terse response. 0.84. What is the ratio of the Aid flow from UN agencies (US$) of Middle income in 1996 to that in 1998?
Your answer should be very brief. 0.79. What is the ratio of the Aid flow from UN agencies (US$) in Upper middle income in 1996 to that in 1998?
Keep it short and to the point. 0.81. What is the ratio of the Aid flow from UN agencies (US$) of Jordan in 1996 to that in 1998?
Offer a terse response. 0.86. What is the ratio of the Aid flow from UN agencies (US$) in Lebanon in 1996 to that in 1998?
Offer a terse response. 0.73. What is the ratio of the Aid flow from UN agencies (US$) in Middle income in 1996 to that in 1999?
Ensure brevity in your answer.  0.83. What is the ratio of the Aid flow from UN agencies (US$) in Upper middle income in 1996 to that in 1999?
Give a very brief answer. 0.79. What is the ratio of the Aid flow from UN agencies (US$) of Jordan in 1996 to that in 1999?
Make the answer very short. 0.79. What is the ratio of the Aid flow from UN agencies (US$) of Lebanon in 1996 to that in 1999?
Your answer should be compact. 0.8. What is the ratio of the Aid flow from UN agencies (US$) of Middle income in 1996 to that in 2000?
Your answer should be compact. 0.79. What is the ratio of the Aid flow from UN agencies (US$) of Upper middle income in 1996 to that in 2000?
Give a very brief answer. 0.79. What is the ratio of the Aid flow from UN agencies (US$) of Jordan in 1996 to that in 2000?
Make the answer very short. 0.82. What is the ratio of the Aid flow from UN agencies (US$) in Lebanon in 1996 to that in 2000?
Offer a terse response. 0.73. What is the ratio of the Aid flow from UN agencies (US$) in Middle income in 1996 to that in 2001?
Provide a short and direct response. 0.66. What is the ratio of the Aid flow from UN agencies (US$) in Upper middle income in 1996 to that in 2001?
Keep it short and to the point. 0.79. What is the ratio of the Aid flow from UN agencies (US$) of Jordan in 1996 to that in 2001?
Make the answer very short. 0.82. What is the ratio of the Aid flow from UN agencies (US$) in Lebanon in 1996 to that in 2001?
Your response must be concise. 0.73. What is the ratio of the Aid flow from UN agencies (US$) in Middle income in 1997 to that in 1998?
Make the answer very short. 0.88. What is the ratio of the Aid flow from UN agencies (US$) in Upper middle income in 1997 to that in 1998?
Ensure brevity in your answer.  0.96. What is the ratio of the Aid flow from UN agencies (US$) in Jordan in 1997 to that in 1998?
Your answer should be very brief. 1.01. What is the ratio of the Aid flow from UN agencies (US$) in Lebanon in 1997 to that in 1998?
Make the answer very short. 0.87. What is the ratio of the Aid flow from UN agencies (US$) in Middle income in 1997 to that in 1999?
Keep it short and to the point. 0.92. What is the ratio of the Aid flow from UN agencies (US$) in Upper middle income in 1997 to that in 1999?
Offer a very short reply. 0.93. What is the ratio of the Aid flow from UN agencies (US$) in Jordan in 1997 to that in 1999?
Your response must be concise. 0.93. What is the ratio of the Aid flow from UN agencies (US$) in Lebanon in 1997 to that in 1999?
Your answer should be very brief. 0.95. What is the ratio of the Aid flow from UN agencies (US$) of Middle income in 1997 to that in 2000?
Offer a very short reply. 0.88. What is the ratio of the Aid flow from UN agencies (US$) of Upper middle income in 1997 to that in 2000?
Make the answer very short. 0.93. What is the ratio of the Aid flow from UN agencies (US$) in Jordan in 1997 to that in 2000?
Offer a very short reply. 0.97. What is the ratio of the Aid flow from UN agencies (US$) in Lebanon in 1997 to that in 2000?
Offer a terse response. 0.87. What is the ratio of the Aid flow from UN agencies (US$) of Middle income in 1997 to that in 2001?
Offer a terse response. 0.73. What is the ratio of the Aid flow from UN agencies (US$) in Upper middle income in 1997 to that in 2001?
Provide a short and direct response. 0.93. What is the ratio of the Aid flow from UN agencies (US$) of Jordan in 1997 to that in 2001?
Keep it short and to the point. 0.96. What is the ratio of the Aid flow from UN agencies (US$) in Lebanon in 1997 to that in 2001?
Provide a short and direct response. 0.88. What is the ratio of the Aid flow from UN agencies (US$) in Middle income in 1998 to that in 1999?
Your answer should be compact. 1.04. What is the ratio of the Aid flow from UN agencies (US$) of Upper middle income in 1998 to that in 1999?
Your answer should be compact. 0.98. What is the ratio of the Aid flow from UN agencies (US$) in Jordan in 1998 to that in 1999?
Provide a short and direct response. 0.92. What is the ratio of the Aid flow from UN agencies (US$) of Lebanon in 1998 to that in 1999?
Provide a succinct answer. 1.09. What is the ratio of the Aid flow from UN agencies (US$) of Middle income in 1998 to that in 2000?
Provide a short and direct response. 0.99. What is the ratio of the Aid flow from UN agencies (US$) of Upper middle income in 1998 to that in 2000?
Provide a succinct answer. 0.97. What is the ratio of the Aid flow from UN agencies (US$) in Jordan in 1998 to that in 2000?
Provide a succinct answer. 0.96. What is the ratio of the Aid flow from UN agencies (US$) of Lebanon in 1998 to that in 2000?
Provide a short and direct response. 1. What is the ratio of the Aid flow from UN agencies (US$) of Middle income in 1998 to that in 2001?
Your response must be concise. 0.83. What is the ratio of the Aid flow from UN agencies (US$) of Upper middle income in 1998 to that in 2001?
Provide a short and direct response. 0.97. What is the ratio of the Aid flow from UN agencies (US$) in Jordan in 1998 to that in 2001?
Your answer should be compact. 0.95. What is the ratio of the Aid flow from UN agencies (US$) of Lebanon in 1998 to that in 2001?
Keep it short and to the point. 1. What is the ratio of the Aid flow from UN agencies (US$) in Middle income in 1999 to that in 2000?
Offer a very short reply. 0.95. What is the ratio of the Aid flow from UN agencies (US$) of Upper middle income in 1999 to that in 2000?
Ensure brevity in your answer.  1. What is the ratio of the Aid flow from UN agencies (US$) of Jordan in 1999 to that in 2000?
Provide a short and direct response. 1.05. What is the ratio of the Aid flow from UN agencies (US$) in Lebanon in 1999 to that in 2000?
Offer a terse response. 0.91. What is the ratio of the Aid flow from UN agencies (US$) of Middle income in 1999 to that in 2001?
Provide a short and direct response. 0.8. What is the ratio of the Aid flow from UN agencies (US$) of Jordan in 1999 to that in 2001?
Offer a terse response. 1.04. What is the ratio of the Aid flow from UN agencies (US$) in Lebanon in 1999 to that in 2001?
Your answer should be very brief. 0.92. What is the ratio of the Aid flow from UN agencies (US$) in Middle income in 2000 to that in 2001?
Ensure brevity in your answer.  0.84. What is the difference between the highest and the second highest Aid flow from UN agencies (US$) in Middle income?
Make the answer very short. 3.38e+07. What is the difference between the highest and the second highest Aid flow from UN agencies (US$) of Upper middle income?
Make the answer very short. 9.00e+04. What is the difference between the highest and the second highest Aid flow from UN agencies (US$) of Jordan?
Provide a succinct answer. 3.23e+06. What is the difference between the highest and the second highest Aid flow from UN agencies (US$) in Lebanon?
Your answer should be compact. 2.10e+05. What is the difference between the highest and the lowest Aid flow from UN agencies (US$) of Middle income?
Your answer should be compact. 1.23e+08. What is the difference between the highest and the lowest Aid flow from UN agencies (US$) of Upper middle income?
Ensure brevity in your answer.  2.71e+07. What is the difference between the highest and the lowest Aid flow from UN agencies (US$) of Jordan?
Offer a terse response. 1.78e+07. What is the difference between the highest and the lowest Aid flow from UN agencies (US$) of Lebanon?
Provide a short and direct response. 1.29e+07. 